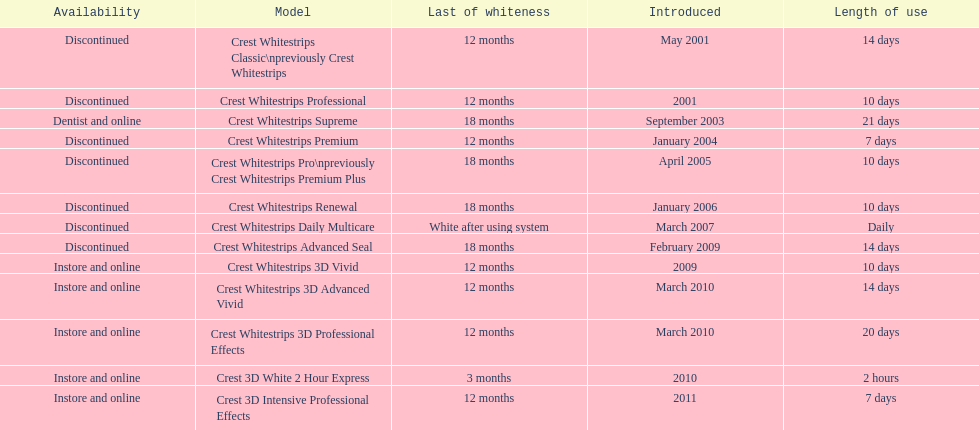What are all of the model names? Crest Whitestrips Classic\npreviously Crest Whitestrips, Crest Whitestrips Professional, Crest Whitestrips Supreme, Crest Whitestrips Premium, Crest Whitestrips Pro\npreviously Crest Whitestrips Premium Plus, Crest Whitestrips Renewal, Crest Whitestrips Daily Multicare, Crest Whitestrips Advanced Seal, Crest Whitestrips 3D Vivid, Crest Whitestrips 3D Advanced Vivid, Crest Whitestrips 3D Professional Effects, Crest 3D White 2 Hour Express, Crest 3D Intensive Professional Effects. When were they first introduced? May 2001, 2001, September 2003, January 2004, April 2005, January 2006, March 2007, February 2009, 2009, March 2010, March 2010, 2010, 2011. Along with crest whitestrips 3d advanced vivid, which other model was introduced in march 2010? Crest Whitestrips 3D Professional Effects. 